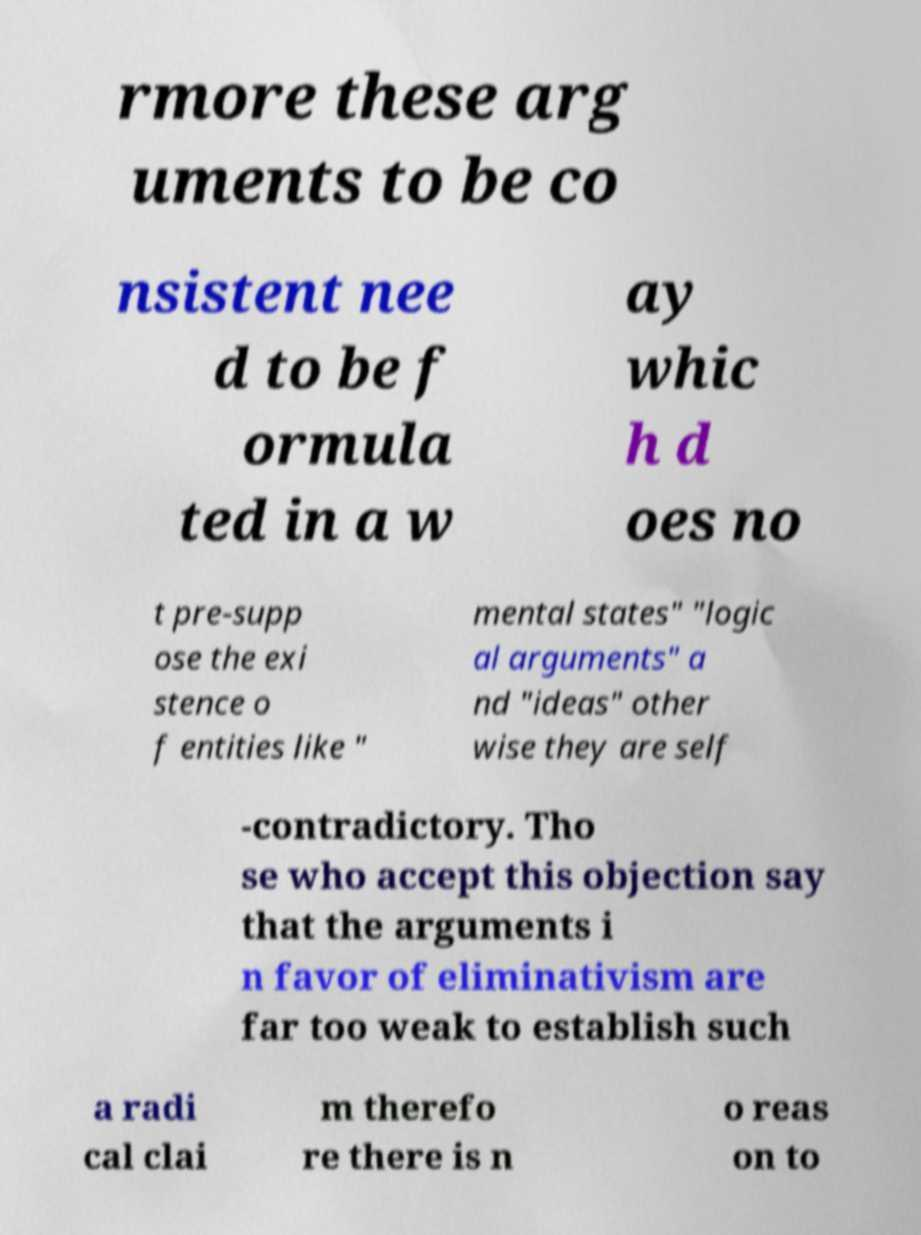What messages or text are displayed in this image? I need them in a readable, typed format. rmore these arg uments to be co nsistent nee d to be f ormula ted in a w ay whic h d oes no t pre-supp ose the exi stence o f entities like " mental states" "logic al arguments" a nd "ideas" other wise they are self -contradictory. Tho se who accept this objection say that the arguments i n favor of eliminativism are far too weak to establish such a radi cal clai m therefo re there is n o reas on to 